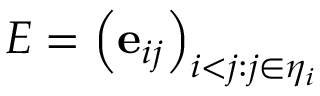<formula> <loc_0><loc_0><loc_500><loc_500>E = \left ( e _ { i j } \right ) _ { i < j \colon j \in \eta _ { i } }</formula> 